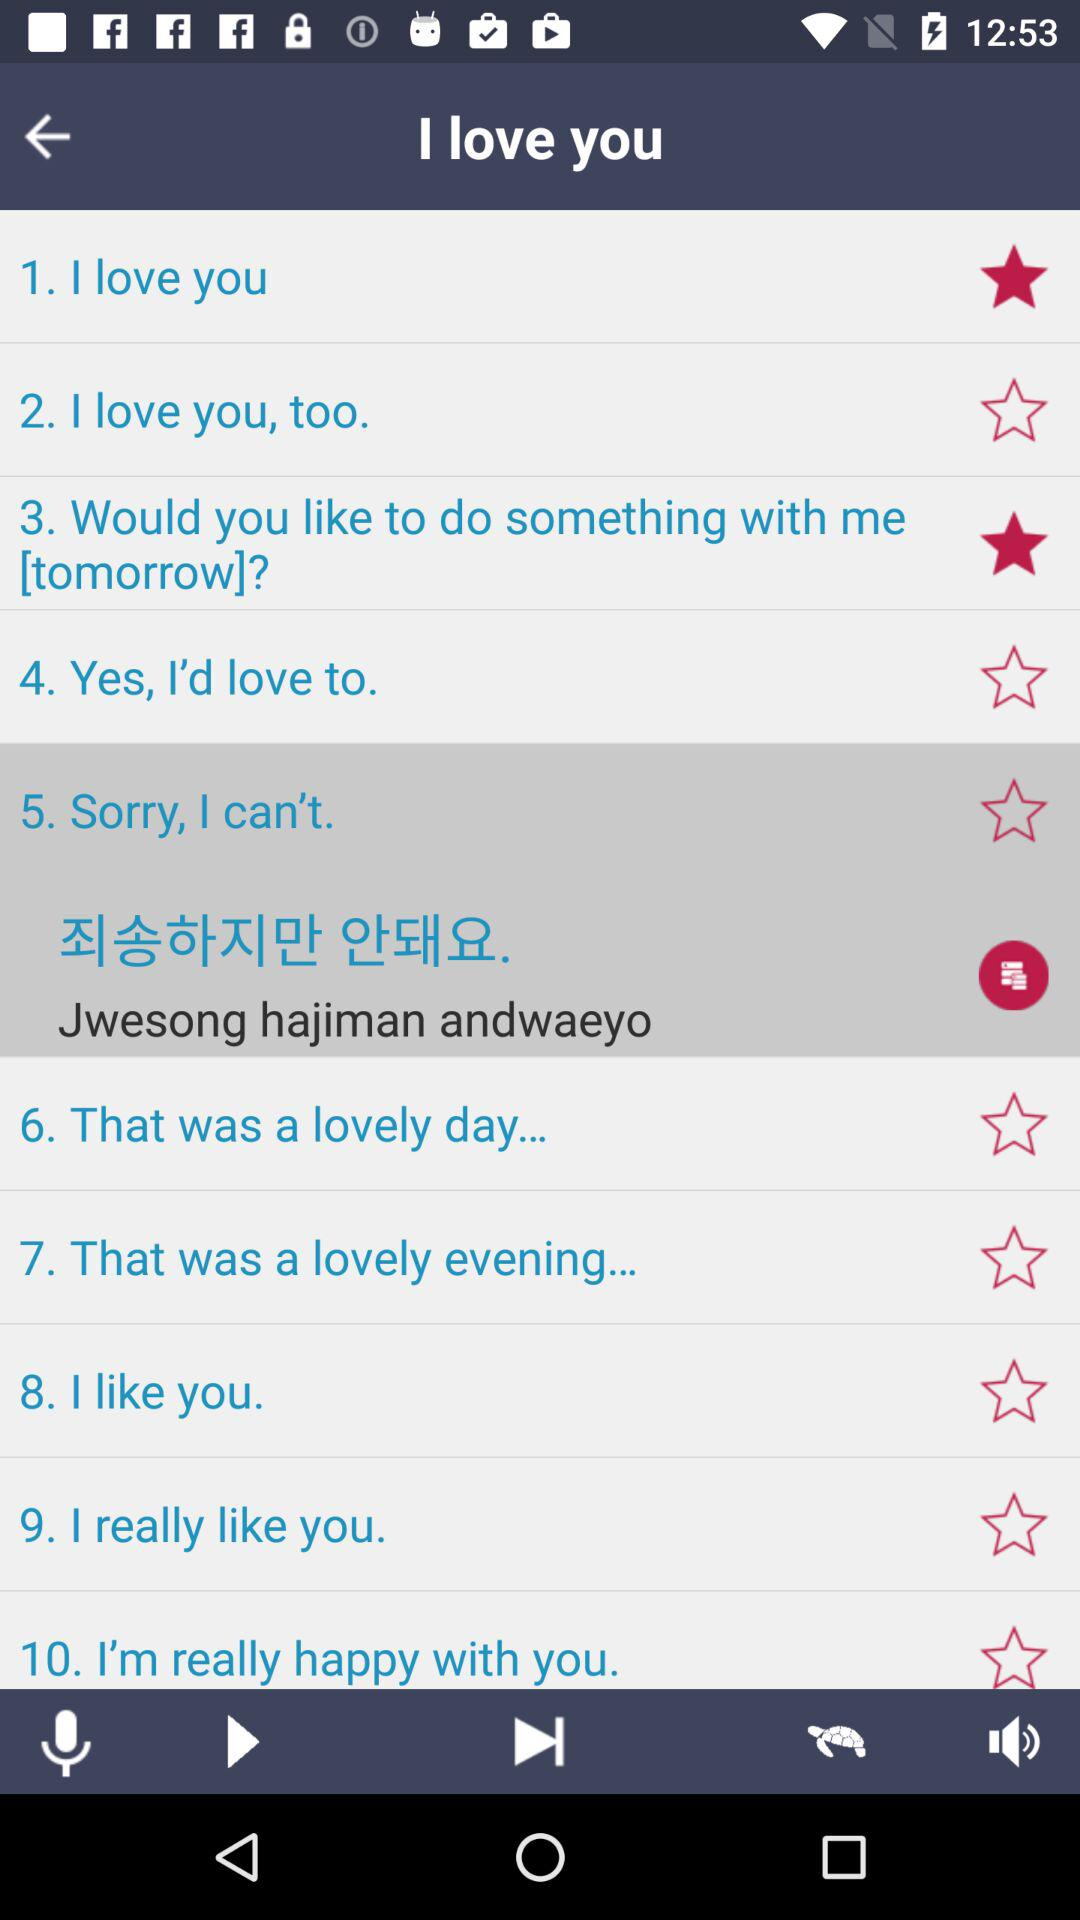Which are the selected stars? The selected stars are: " I love you", and "3. Would you like to do something with me [tomorrrow]?". 